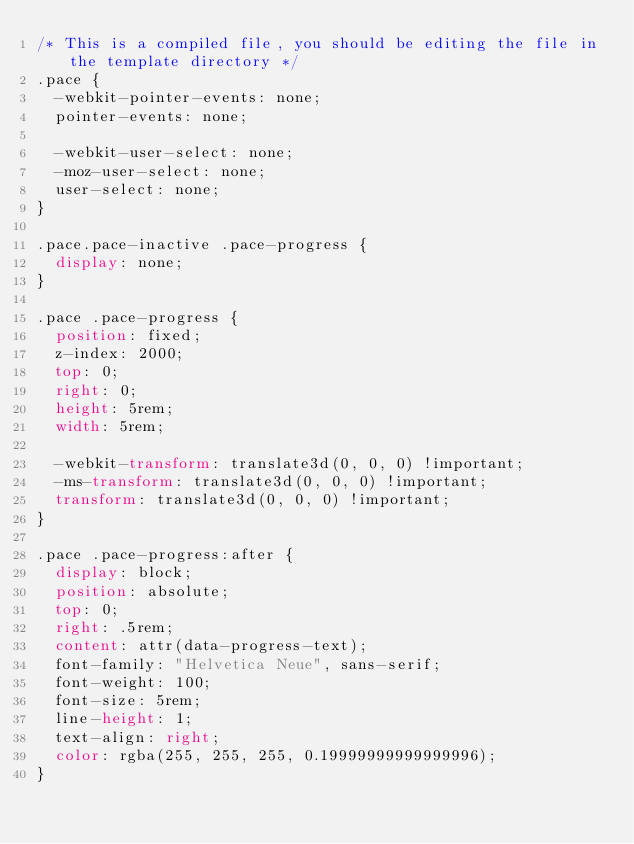Convert code to text. <code><loc_0><loc_0><loc_500><loc_500><_CSS_>/* This is a compiled file, you should be editing the file in the template directory */
.pace {
  -webkit-pointer-events: none;
  pointer-events: none;

  -webkit-user-select: none;
  -moz-user-select: none;
  user-select: none;
}

.pace.pace-inactive .pace-progress {
  display: none;
}

.pace .pace-progress {
  position: fixed;
  z-index: 2000;
  top: 0;
  right: 0;
  height: 5rem;
  width: 5rem;

  -webkit-transform: translate3d(0, 0, 0) !important;
  -ms-transform: translate3d(0, 0, 0) !important;
  transform: translate3d(0, 0, 0) !important;
}

.pace .pace-progress:after {
  display: block;
  position: absolute;
  top: 0;
  right: .5rem;
  content: attr(data-progress-text);
  font-family: "Helvetica Neue", sans-serif;
  font-weight: 100;
  font-size: 5rem;
  line-height: 1;
  text-align: right;
  color: rgba(255, 255, 255, 0.19999999999999996);
}
</code> 